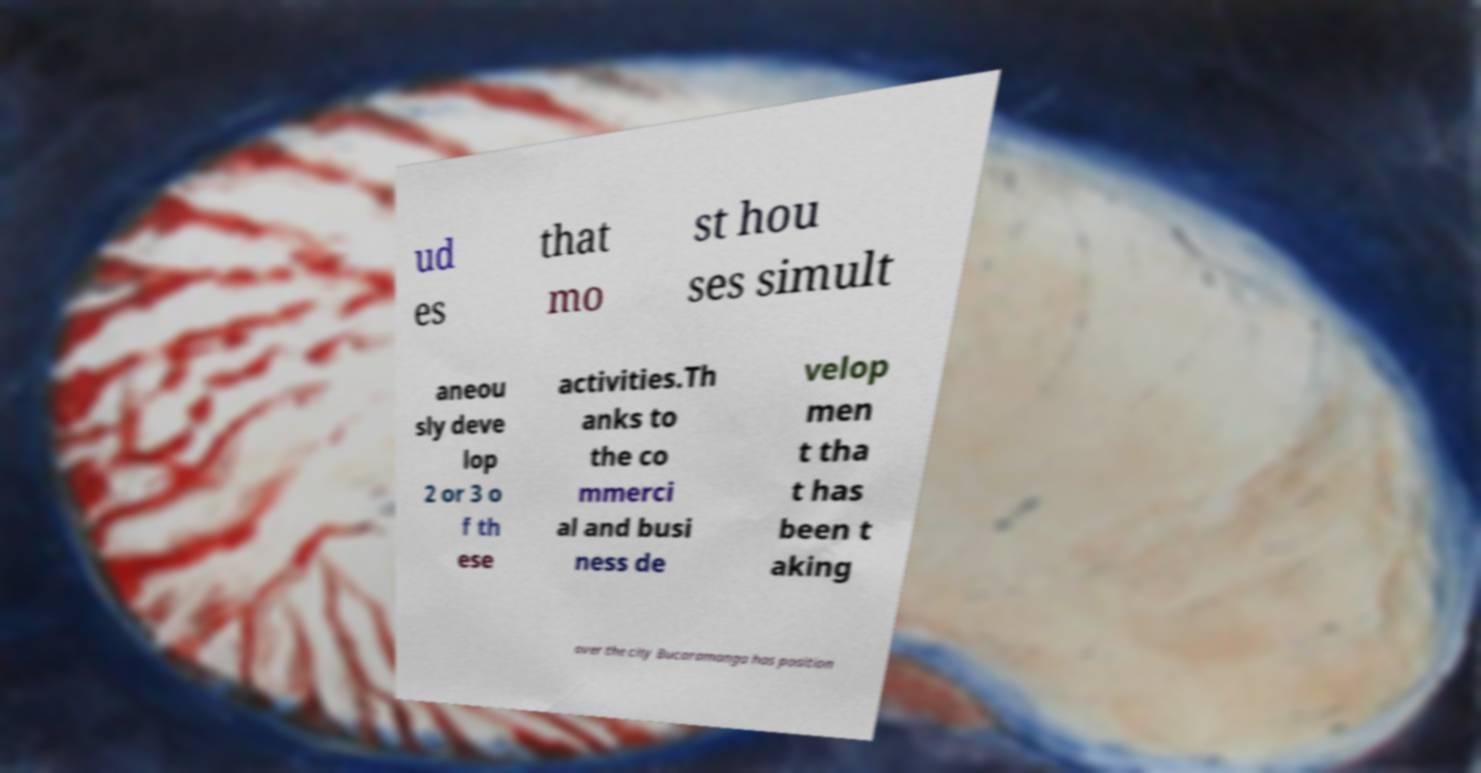What messages or text are displayed in this image? I need them in a readable, typed format. ud es that mo st hou ses simult aneou sly deve lop 2 or 3 o f th ese activities.Th anks to the co mmerci al and busi ness de velop men t tha t has been t aking over the city Bucaramanga has position 